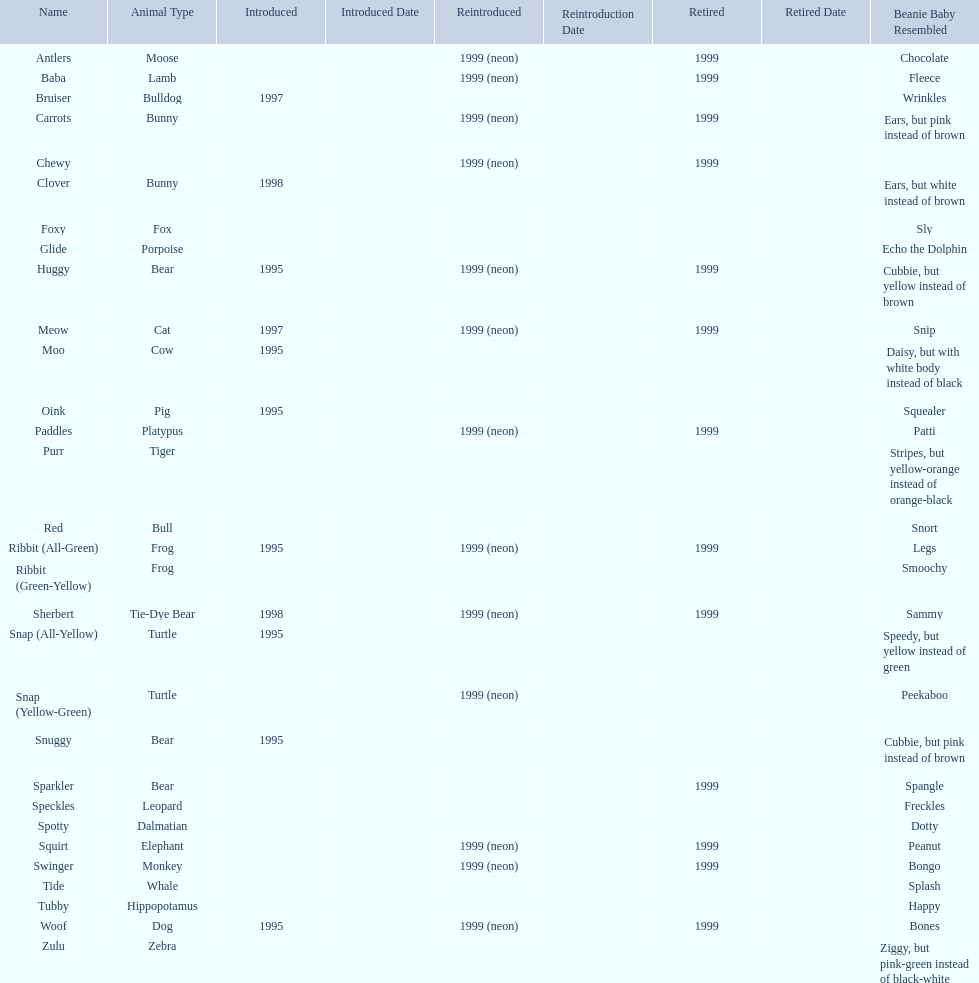Which is the only pillow pal without a listed animal type? Chewy. 